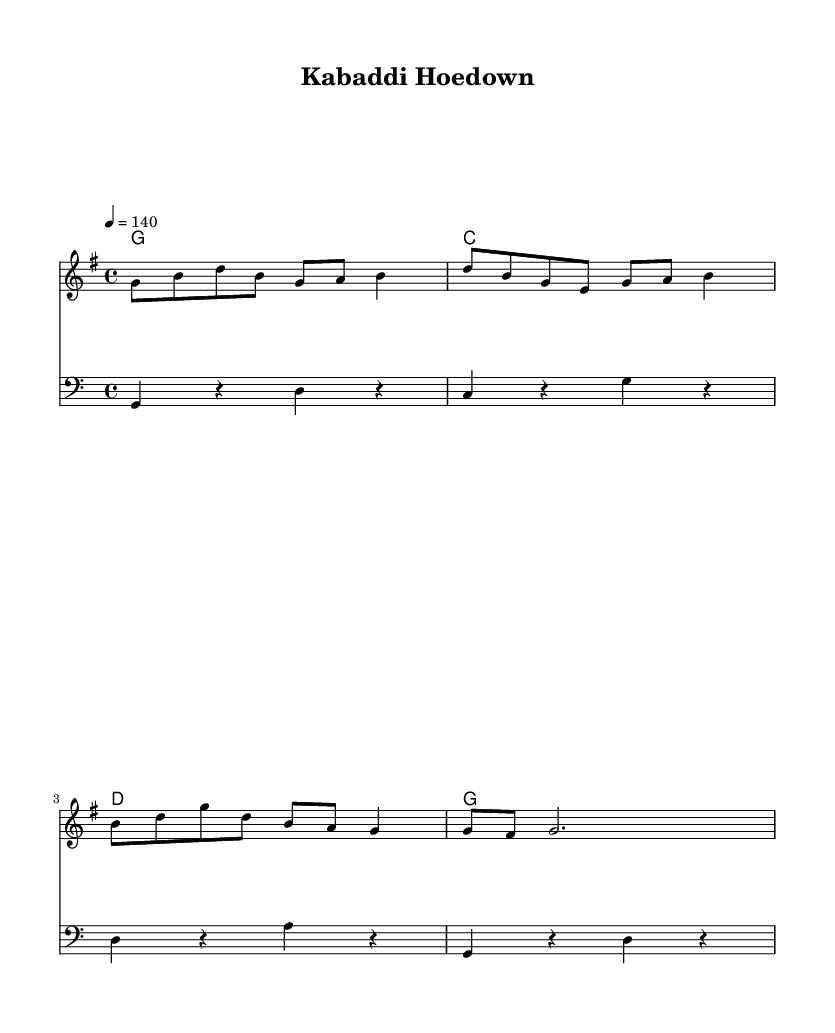What is the key signature of this music? The key signature is G major, which has one sharp (F#). You can identify the key signature by looking at the key signature section at the beginning of the staff.
Answer: G major What is the time signature of this piece? The time signature is 4/4, which indicates there are four beats in each measure and the quarter note gets one beat. This is visible at the beginning of the score after the key signature.
Answer: 4/4 What is the tempo marking for this piece? The tempo marking is 140 beats per minute, indicated by the notation "4 = 140" at the beginning of the piece. This tells musicians how fast to play the piece.
Answer: 140 How many measures does the melody have? The melody consists of four measures, easily counted by looking at the bars in the notation, with each bar representing one measure.
Answer: 4 What is the highest pitch note in the melody? The highest pitch note in the melody is D, which can be found by analyzing the melody line shown in the notation. The highest note appears on the second beat of the third measure.
Answer: D What type of chords are used in the harmony section? The harmony section uses major chords, specifically G, C, and D major chords, as indicated by the chord symbols above the staff. Each chord corresponds to the notes played underneath in the melody.
Answer: Major chords How does the bass line relate to the melody? The bass line provides a foundational counterpoint to the melody, with its notes generally supporting the harmony by playing root notes of the chords. By examining the bass notes, you can see how they match the chords in the harmony section.
Answer: Counterpoint 